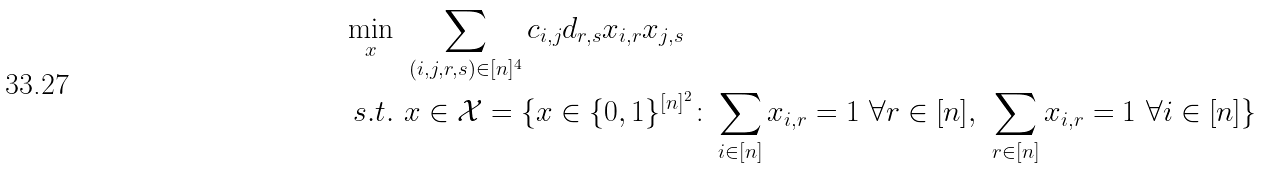<formula> <loc_0><loc_0><loc_500><loc_500>\min _ { x } & \ \sum _ { ( i , j , r , s ) \in [ n ] ^ { 4 } } c _ { i , j } d _ { r , s } x _ { i , r } x _ { j , s } \\ s . t . & \ x \in \mathcal { X } = \{ x \in \{ 0 , 1 \} ^ { [ n ] ^ { 2 } } \colon \sum _ { i \in [ n ] } x _ { i , r } = 1 \ \forall r \in [ n ] , \ \sum _ { r \in [ n ] } x _ { i , r } = 1 \ \forall i \in [ n ] \}</formula> 